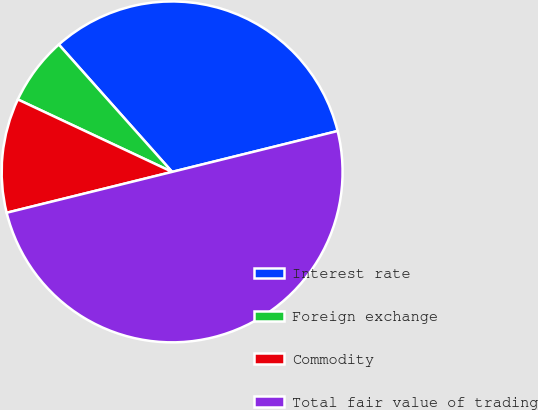Convert chart to OTSL. <chart><loc_0><loc_0><loc_500><loc_500><pie_chart><fcel>Interest rate<fcel>Foreign exchange<fcel>Commodity<fcel>Total fair value of trading<nl><fcel>32.72%<fcel>6.44%<fcel>10.84%<fcel>50.0%<nl></chart> 